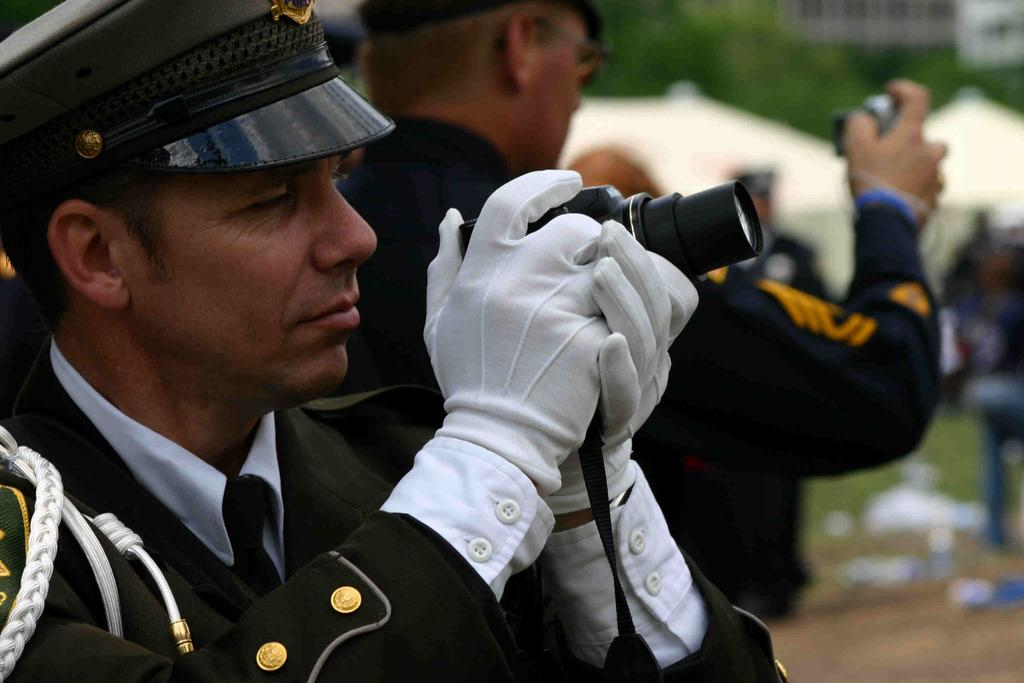What are the persons in the center of the image doing? The persons in the center of the image are holding cameras. What can be seen in the background of the image? There are tents, persons, grass, trees, and buildings in the background of the image. What type of jar is being used to capture the word in the image? There is no jar or word present in the image. What type of tank can be seen in the background of the image? There is no tank present in the image. 